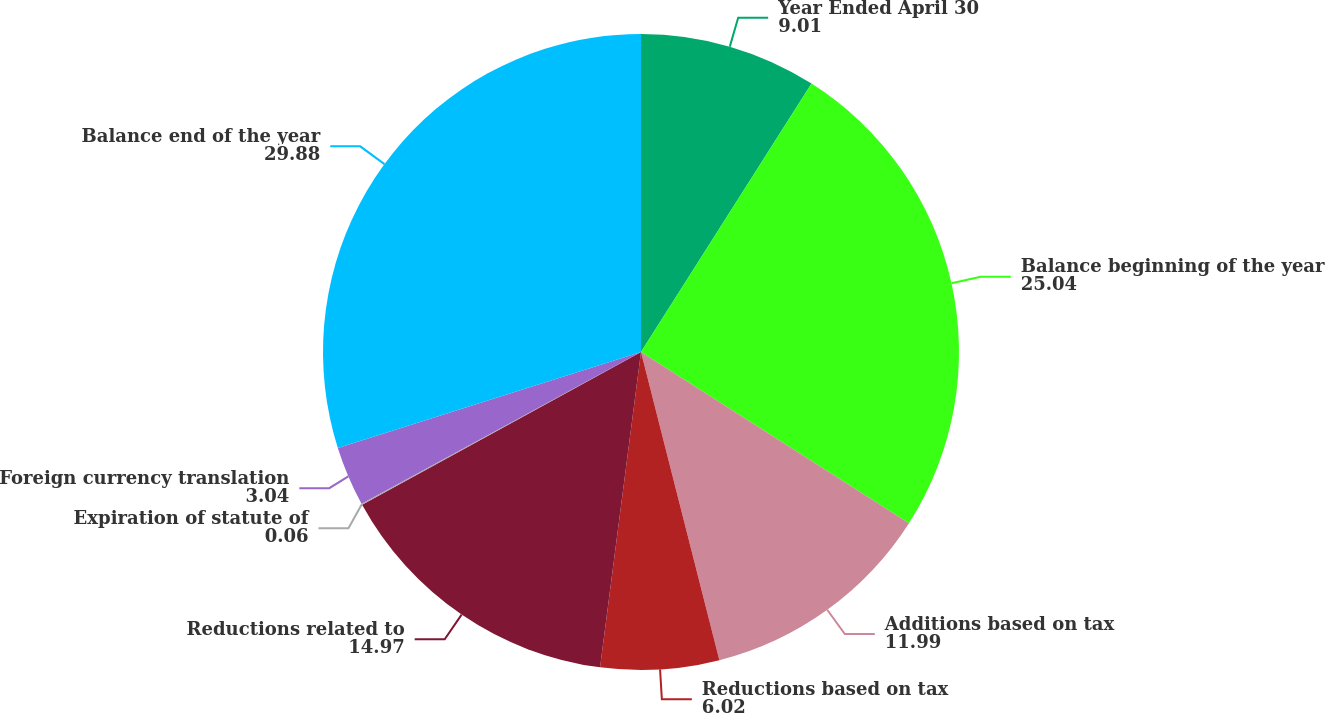<chart> <loc_0><loc_0><loc_500><loc_500><pie_chart><fcel>Year Ended April 30<fcel>Balance beginning of the year<fcel>Additions based on tax<fcel>Reductions based on tax<fcel>Reductions related to<fcel>Expiration of statute of<fcel>Foreign currency translation<fcel>Balance end of the year<nl><fcel>9.01%<fcel>25.04%<fcel>11.99%<fcel>6.02%<fcel>14.97%<fcel>0.06%<fcel>3.04%<fcel>29.88%<nl></chart> 